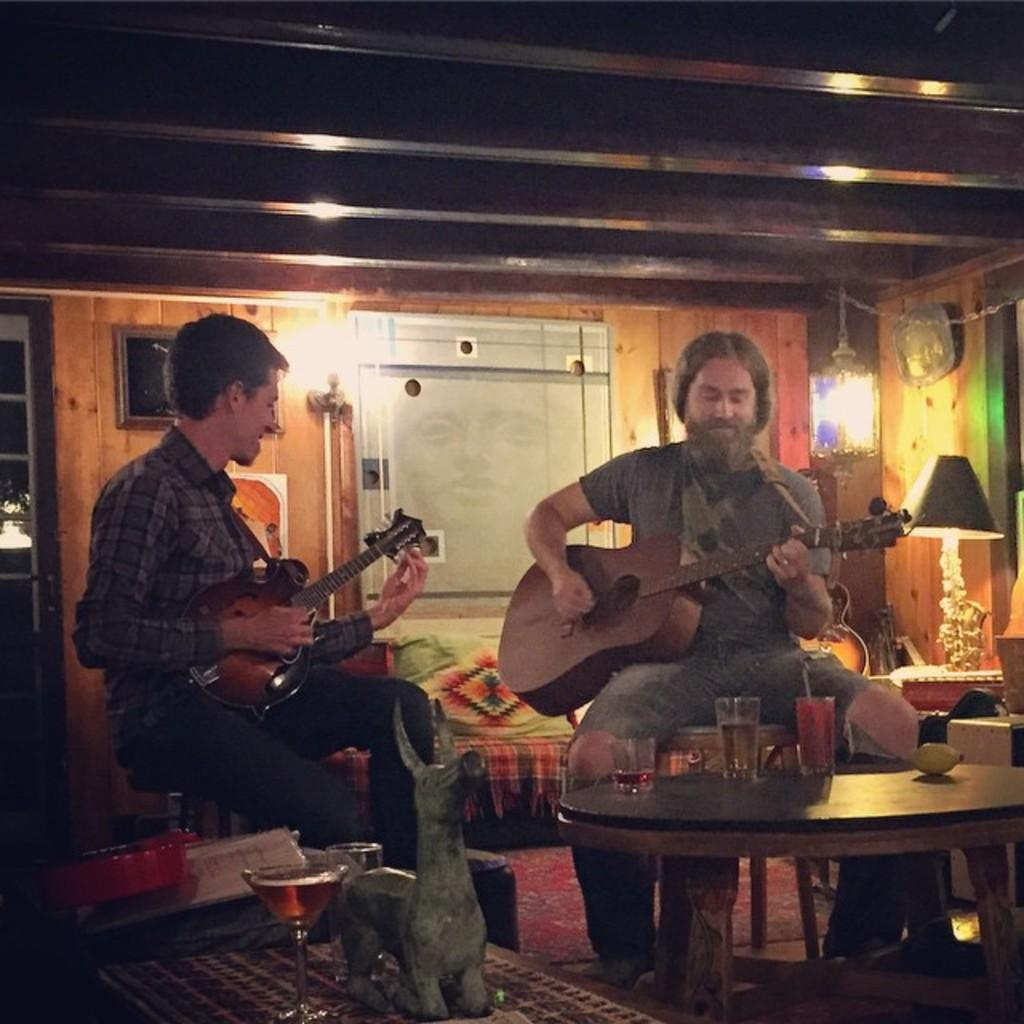What is the main setting of the image? There is a room in the image. What are the two persons in the image doing? The persons are sitting on chairs and playing musical instruments. What is present on the table in the image? There is a glass on the table. What can be seen in the background of the image? There is a wall visible in the background. What type of mountain can be seen through the window in the image? There is no window or mountain present in the image. How many sponges are on the floor in the image? There is no sponge or floor visible in the image. 